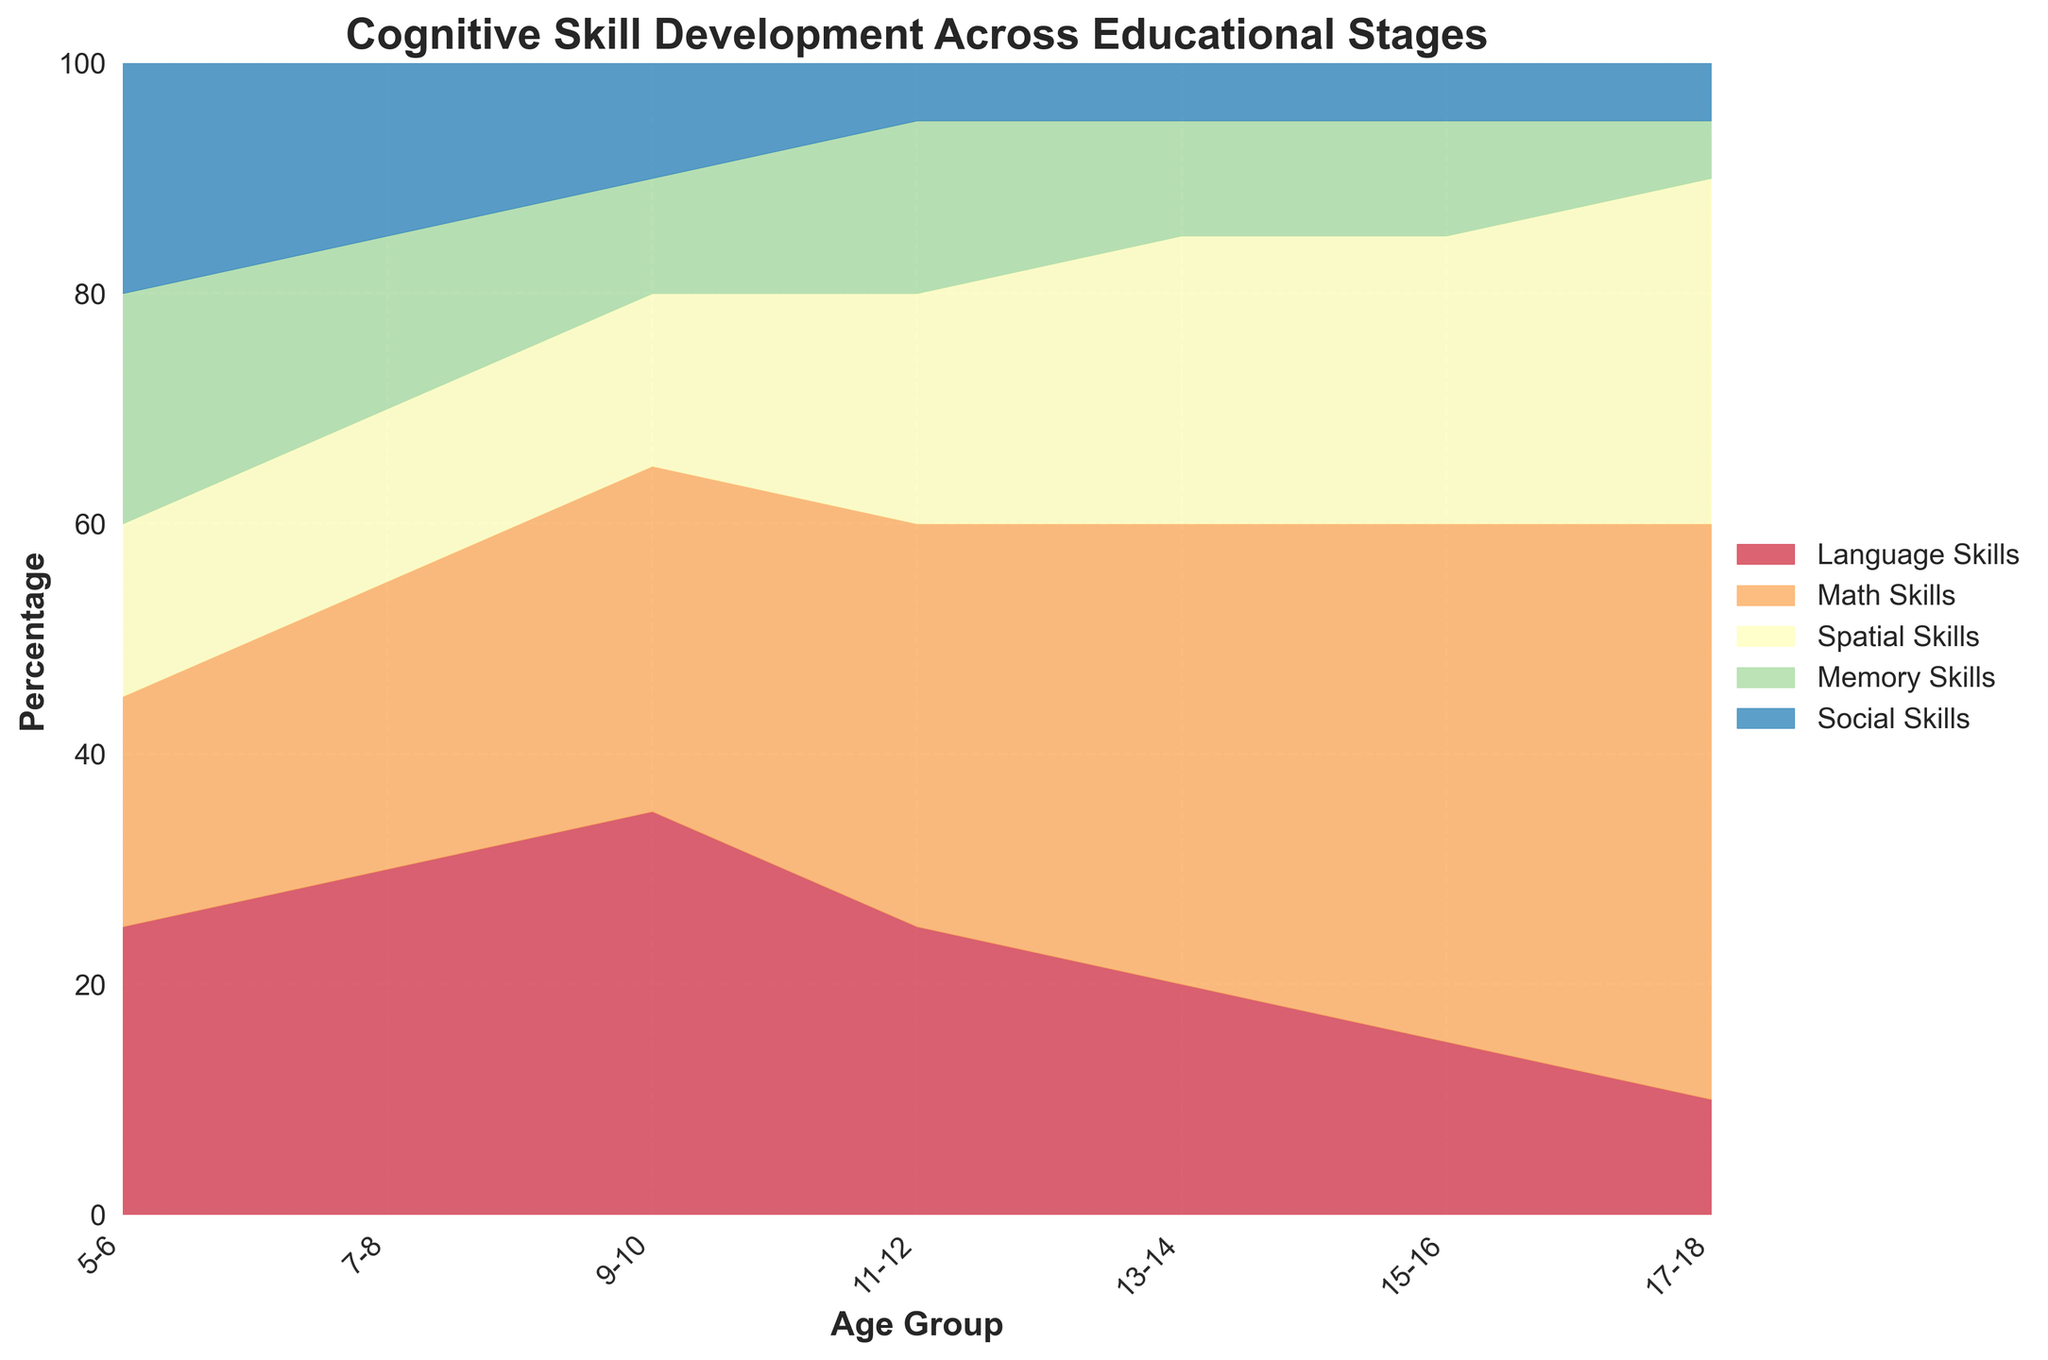What is the title of the figure? The title of the figure is located at the top and provides an overview of what the chart represents. From the plot generation code, the title set is "Cognitive Skill Development Across Educational Stages".
Answer: Cognitive Skill Development Across Educational Stages Which cognitive skill shows the largest percentage for the age group 13-14? To determine which cognitive skill is the largest for the age group 13-14, look at the segments for this age group in the stacked area chart. The Math Skills area is the largest at this age.
Answer: Math Skills At what age group does Math Skills first become the highest percentage skill? Observe the filled areas for each cognitive skill across the age groups from youngest to oldest. The Math Skills area surpasses others starting from the 11-12 age group.
Answer: 11-12 How does the percentage of Social Skills change from age group 5-6 to 17-18? Examine the section of the stacked area chart attributed to Social Skills between these age groups. It decreases consistently.
Answer: Decreases consistently What is the trend in percentage for Memory Skills across the age groups? Look at the Memory Skills section across all age groups in the chart. The percentage decreases from younger to older age groups.
Answer: Decreases Compare the percentage of Language Skills and Spatial Skills in the age group 15-16. Observe both the Language Skills and Spatial Skills areas for the 15-16 age group. Language Skills are smaller compared to Spatial Skills at this age.
Answer: Language Skills are smaller than Spatial Skills Which cognitive skill has the highest percentage for the oldest age group? Check the sections for the oldest age group (17-18). Math Skills have the highest percentage.
Answer: Math Skills What is the difference in percentage of Math Skills between the age groups 5-6 and 17-18? Locate the Math Skills section for both age groups. Subtract the 5-6 percentage (20) from 17-18 (50).
Answer: 30 What percentage of total cognitive skills does Spatial Skills contribute to in the age group 11-12? Identify the total percentage of the Spatial Skills section in the 11-12 age group from the chart. Spatial Skills contributes 20%.
Answer: 20% Why is a 100% Stacked Area Chart used for this figure? A 100% Stacked Area Chart shows the part-to-whole relationships of different cognitive skills across age groups, making it easy to compare relative distributions.
Answer: To show part-to-whole relationships across age groups 